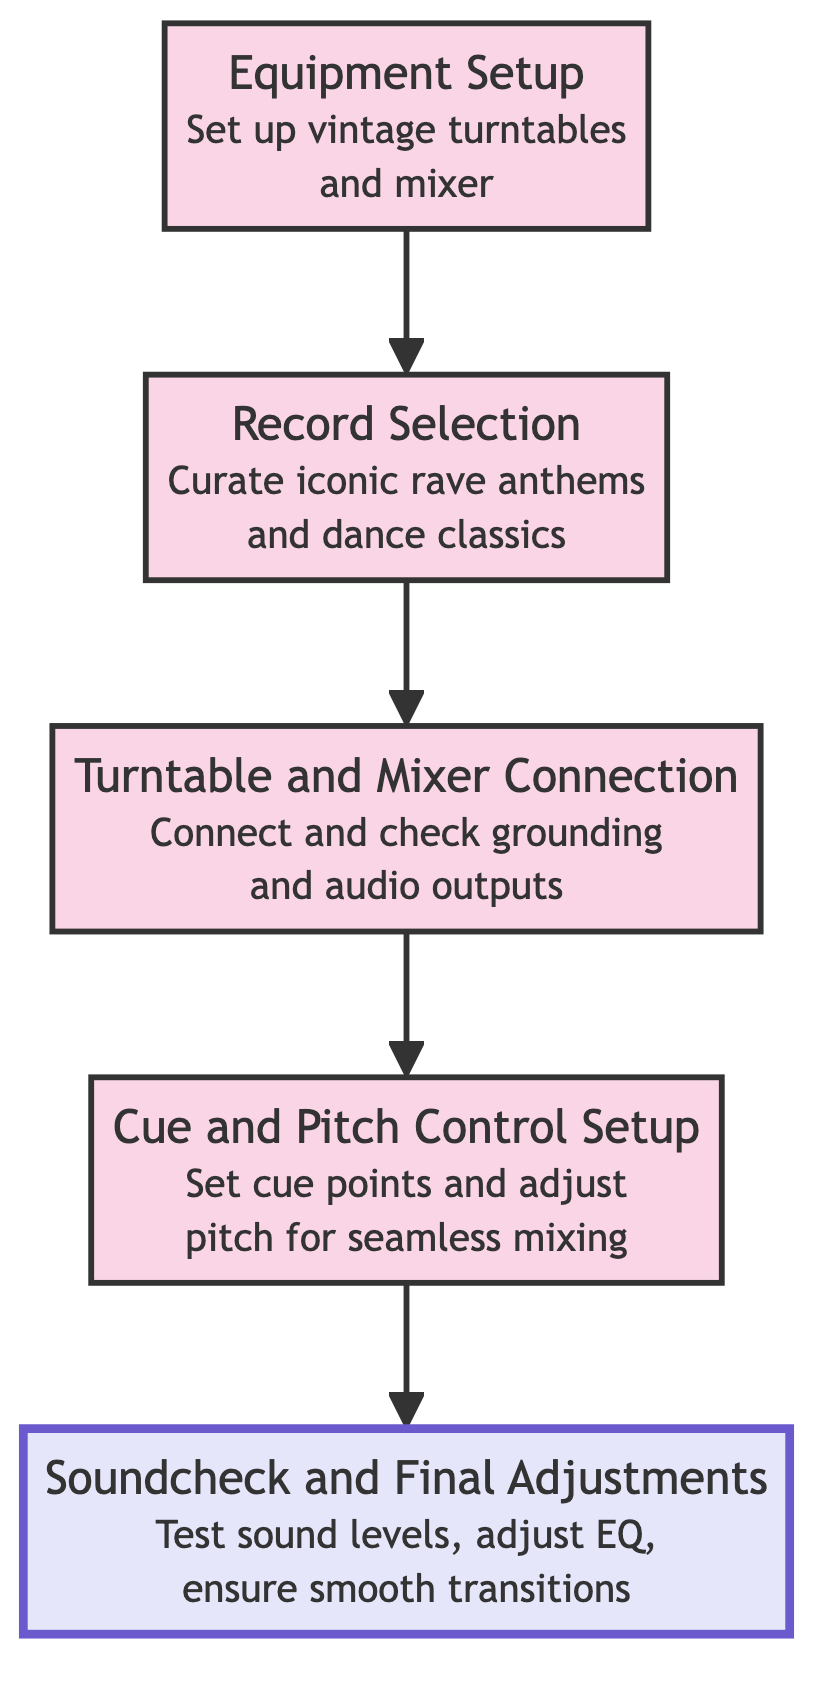what's the last step in the flow chart? The last step in the flow chart, which is at the top, is "Soundcheck and Final Adjustments." This node is the endpoint of the flow described in the diagram.
Answer: Soundcheck and Final Adjustments how many steps are in the flow chart? The flow chart contains five distinct steps, each represented by a different node, moving from "Equipment Setup" to "Soundcheck and Final Adjustments."
Answer: Five what is the first step in the flow chart? The first step in the flow chart, which is at the bottom, is "Equipment Setup." This marks the starting point of the process described.
Answer: Equipment Setup what is the relationship between 'Record Selection' and 'Cue and Pitch Control Setup'? The relationship is sequential; 'Record Selection' is followed by 'Cue and Pitch Control Setup.' This means that after selecting the records, the next action is to set the cue and pitch control.
Answer: Sequential what is the purpose of the 'Turntable and Mixer Connection' step? The purpose is to ensure the turntables are securely connected to the mixer, with a focus on checking grounding and audio outputs. This is a vital step for proper sound before moving to cue setup.
Answer: Ensure connection and check grounding what happens after 'Cue and Pitch Control Setup'? After 'Cue and Pitch Control Setup,' the next step is 'Turntable and Mixer Connection.' This indicates that upon setting cue points and pitch, the focus shifts to ensuring turntable and mixer connections are secure.
Answer: Turntable and Mixer Connection what is the purpose of the flow chart? The purpose of the flow chart is to guide users through the process of setting up a vintage vinyl DJ set, detailing each important step from equipment setup to soundcheck.
Answer: Guide for setting up a DJ set how does 'Soundcheck and Final Adjustments' relate to 'Equipment Setup'? 'Soundcheck and Final Adjustments' is the final step that is preceded by a series of processes starting from 'Equipment Setup,' which means that after setting up the equipment, the sound must be tested and finalized.
Answer: It's the final step after all setups 